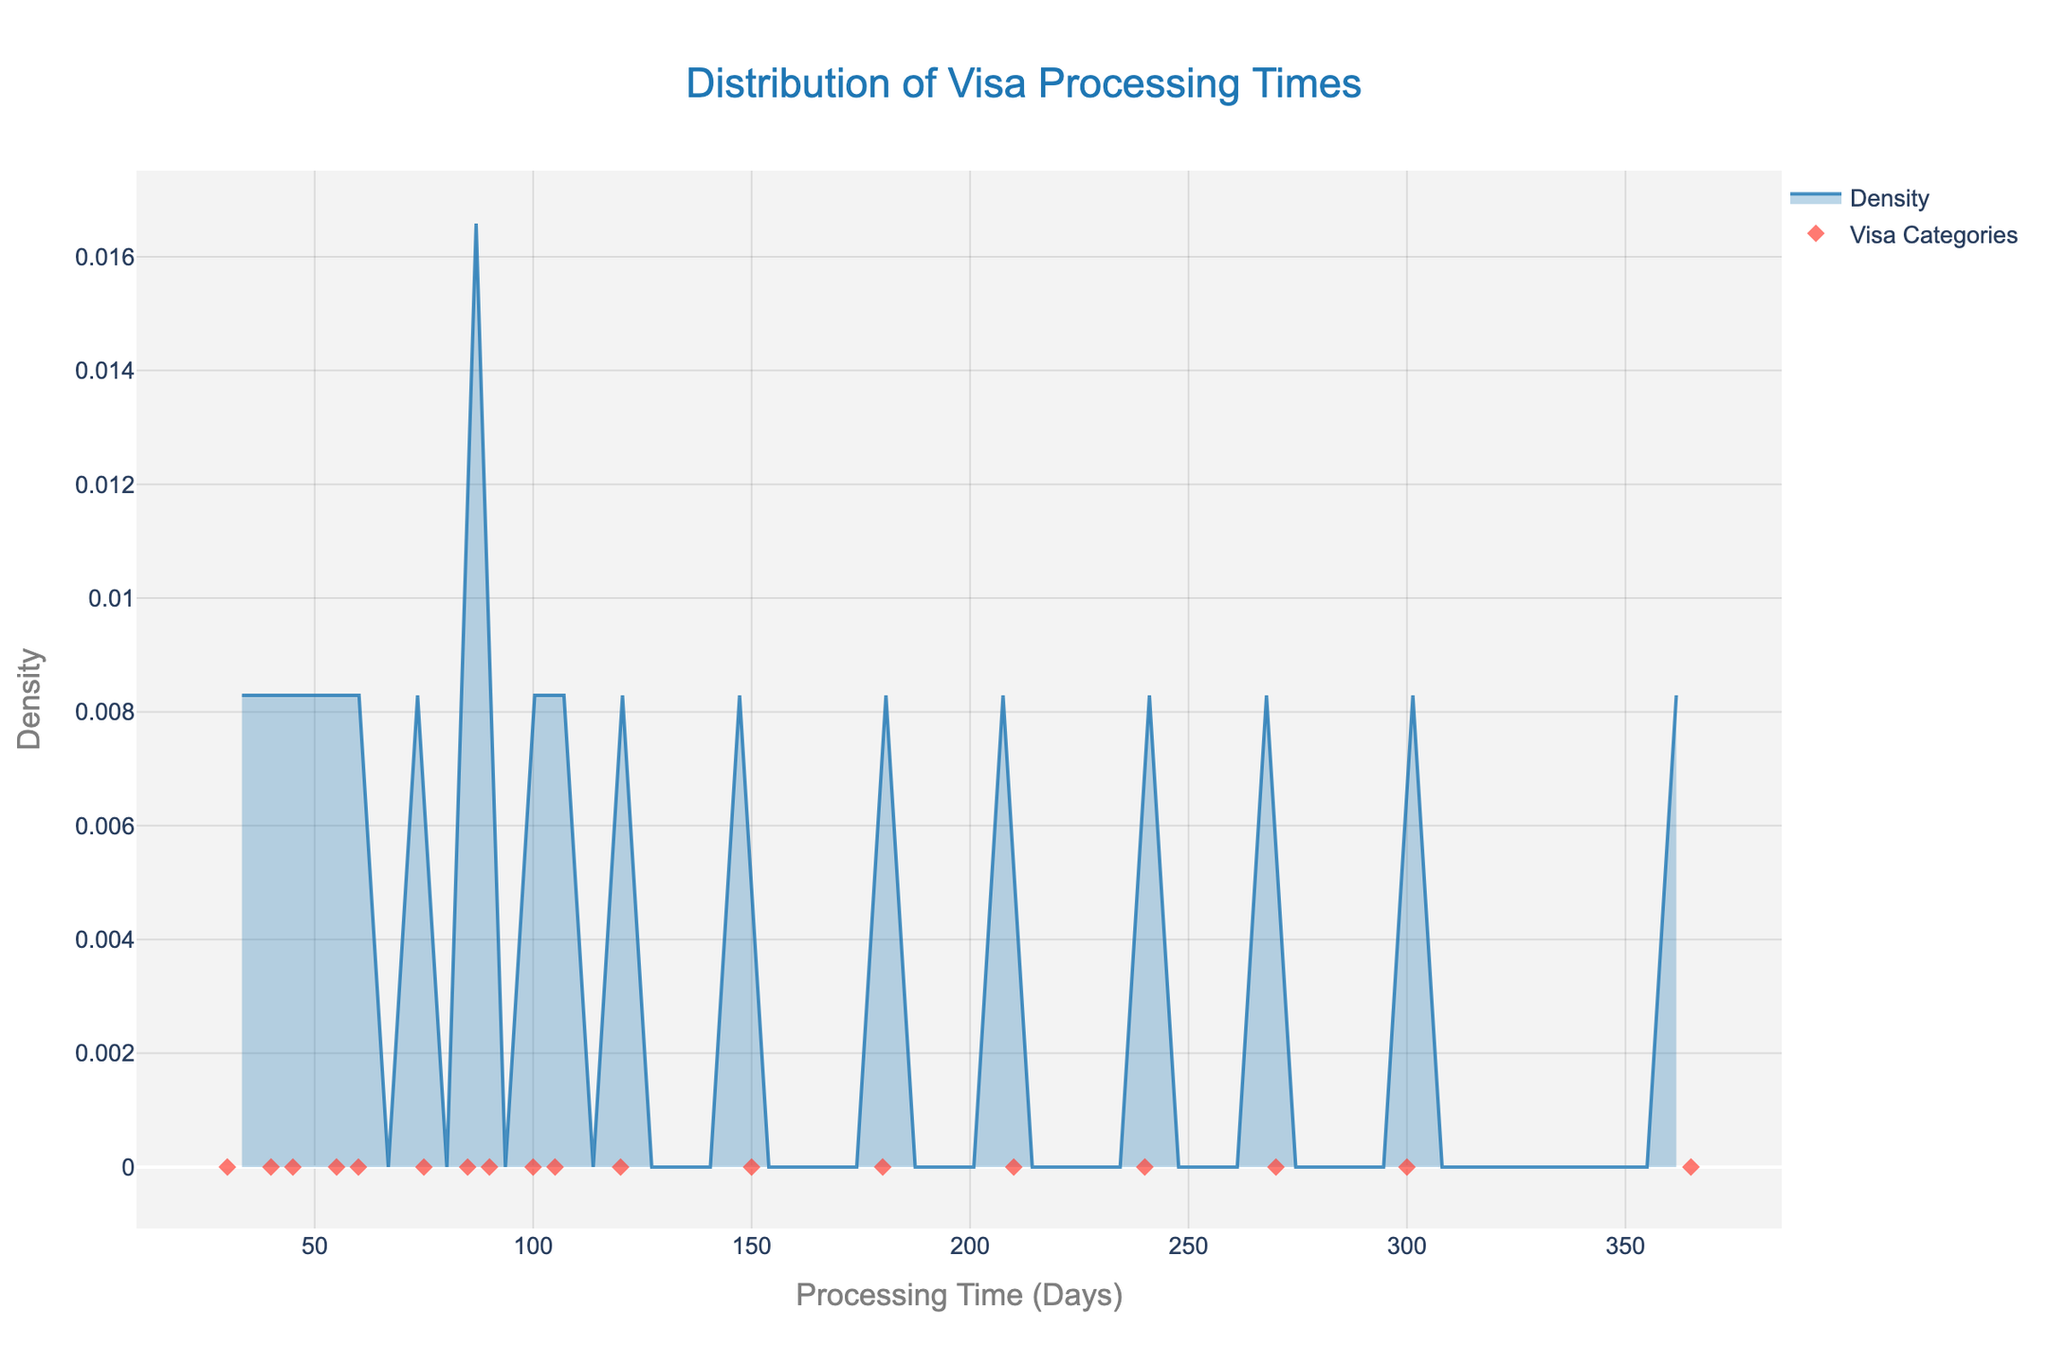What is the title of the plot? The title can be found at the top of the plot.
Answer: Distribution of Visa Processing Times What is the x-axis label? The x-axis label is located below the horizontal axis.
Answer: Processing Time (Days) How many visa categories have a processing time of exactly 150 days? Look for markers on the x-axis aligned with 150 days and read the hover info.
Answer: 1 Which visa category has the longest processing time? Find the point farthest to the right and check its hover info.
Answer: EB-5 Immigrant Investor Which visa category has the shortest processing time? Find the point farthest to the left and check its hover info.
Answer: B-1/B-2 Visitor What is the approximate peak density value in the density plot? Identify the highest point on the density curve and read the y-axis value.
Answer: Approximately 0.008 What is the processing time range where the density is highest? Find where the peak of the density curve is located on the x-axis.
Answer: Around 90-100 days How does the density change as processing time increases from 0 to 365 days? Observe the shape of the density curve from left to right. Note peaks, valleys, and whether the trend increases or decreases.
Answer: The density starts low, peaks around 90-100 days, and then decreases overall How many visa categories have a processing time longer than 200 days? Look for markers to the right of the 200 days mark on the x-axis and count them.
Answer: 5 Compare the processing times of the E-2 Treaty Investor and TN NAFTA Professional visas. Which takes longer? Identify the specific markers for each visa category and compare their x-axis positions.
Answer: E-2 Treaty Investor 